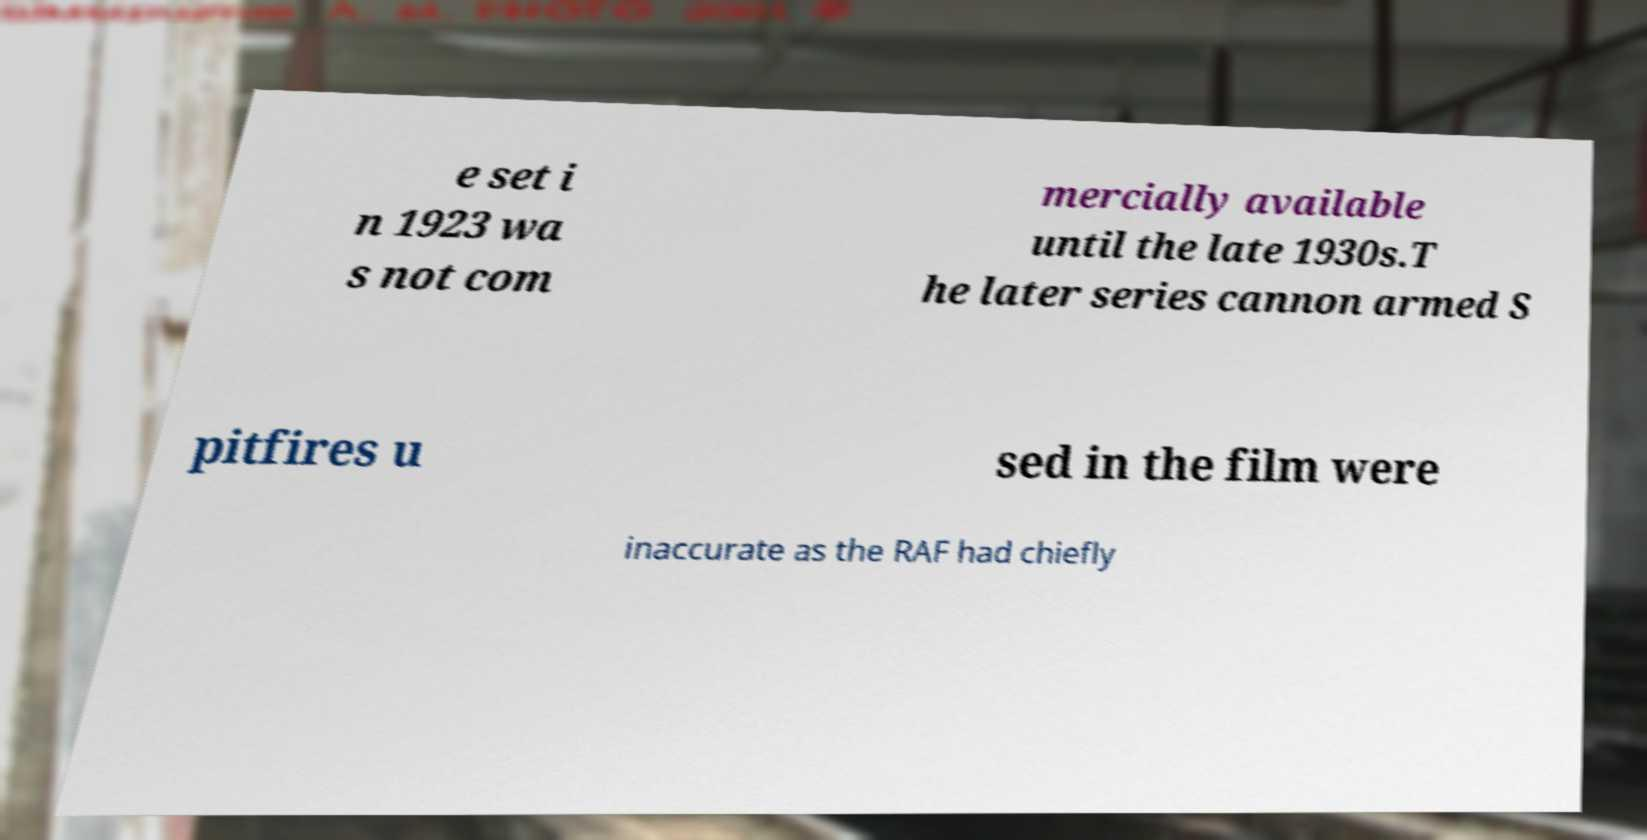Can you read and provide the text displayed in the image?This photo seems to have some interesting text. Can you extract and type it out for me? e set i n 1923 wa s not com mercially available until the late 1930s.T he later series cannon armed S pitfires u sed in the film were inaccurate as the RAF had chiefly 